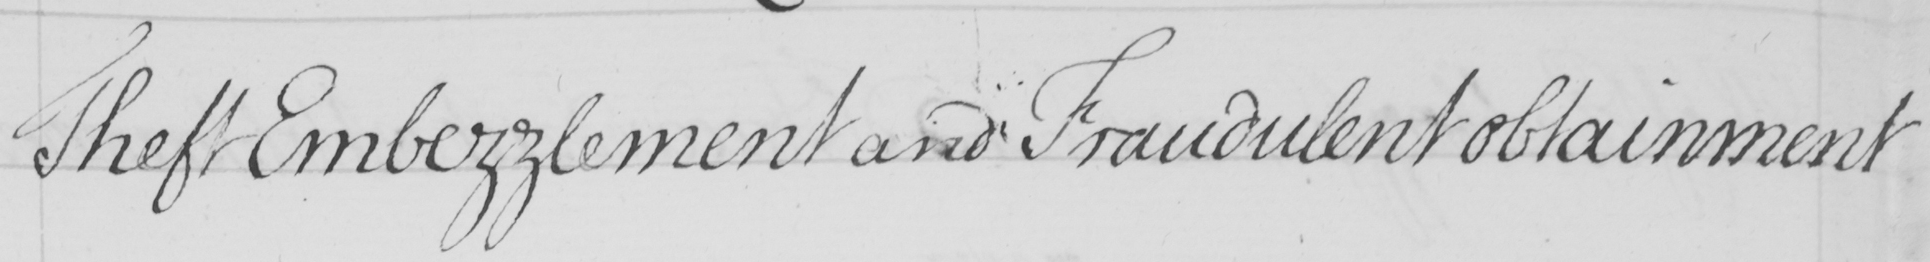Transcribe the text shown in this historical manuscript line. Theft Embezzlement and Fraudulent obtainment 